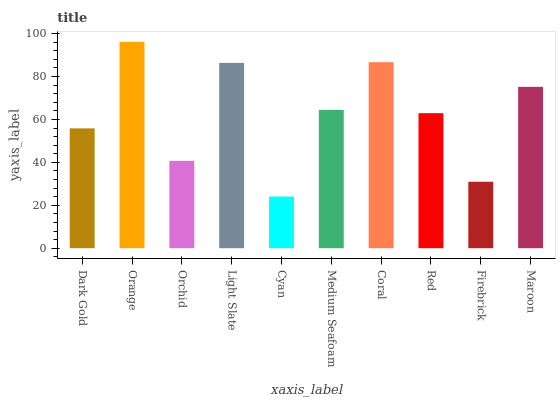Is Cyan the minimum?
Answer yes or no. Yes. Is Orange the maximum?
Answer yes or no. Yes. Is Orchid the minimum?
Answer yes or no. No. Is Orchid the maximum?
Answer yes or no. No. Is Orange greater than Orchid?
Answer yes or no. Yes. Is Orchid less than Orange?
Answer yes or no. Yes. Is Orchid greater than Orange?
Answer yes or no. No. Is Orange less than Orchid?
Answer yes or no. No. Is Medium Seafoam the high median?
Answer yes or no. Yes. Is Red the low median?
Answer yes or no. Yes. Is Maroon the high median?
Answer yes or no. No. Is Coral the low median?
Answer yes or no. No. 